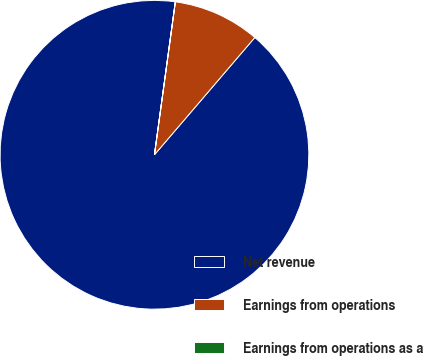<chart> <loc_0><loc_0><loc_500><loc_500><pie_chart><fcel>Net revenue<fcel>Earnings from operations<fcel>Earnings from operations as a<nl><fcel>90.89%<fcel>9.1%<fcel>0.01%<nl></chart> 